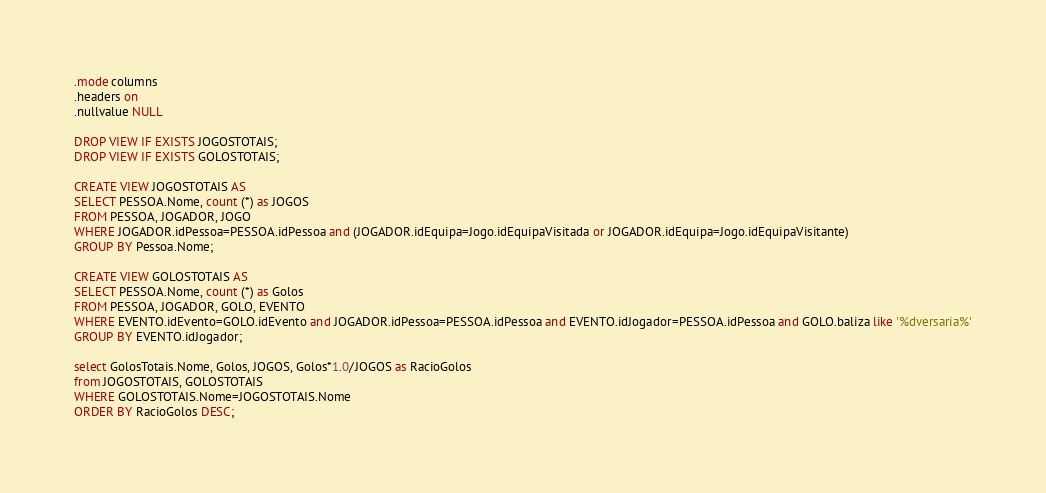<code> <loc_0><loc_0><loc_500><loc_500><_SQL_>.mode columns
.headers on
.nullvalue NULL

DROP VIEW IF EXISTS JOGOSTOTAIS;
DROP VIEW IF EXISTS GOLOSTOTAIS;

CREATE VIEW JOGOSTOTAIS AS
SELECT PESSOA.Nome, count (*) as JOGOS
FROM PESSOA, JOGADOR, JOGO
WHERE JOGADOR.idPessoa=PESSOA.idPessoa and (JOGADOR.idEquipa=Jogo.idEquipaVisitada or JOGADOR.idEquipa=Jogo.idEquipaVisitante)
GROUP BY Pessoa.Nome;

CREATE VIEW GOLOSTOTAIS AS
SELECT PESSOA.Nome, count (*) as Golos
FROM PESSOA, JOGADOR, GOLO, EVENTO
WHERE EVENTO.idEvento=GOLO.idEvento and JOGADOR.idPessoa=PESSOA.idPessoa and EVENTO.idJogador=PESSOA.idPessoa and GOLO.baliza like '%dversaria%'
GROUP BY EVENTO.idJogador;

select GolosTotais.Nome, Golos, JOGOS, Golos*1.0/JOGOS as RacioGolos
from JOGOSTOTAIS, GOLOSTOTAIS
WHERE GOLOSTOTAIS.Nome=JOGOSTOTAIS.Nome
ORDER BY RacioGolos DESC;
</code> 